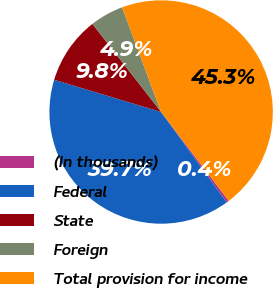Convert chart. <chart><loc_0><loc_0><loc_500><loc_500><pie_chart><fcel>(In thousands)<fcel>Federal<fcel>State<fcel>Foreign<fcel>Total provision for income<nl><fcel>0.36%<fcel>39.65%<fcel>9.8%<fcel>4.86%<fcel>45.33%<nl></chart> 